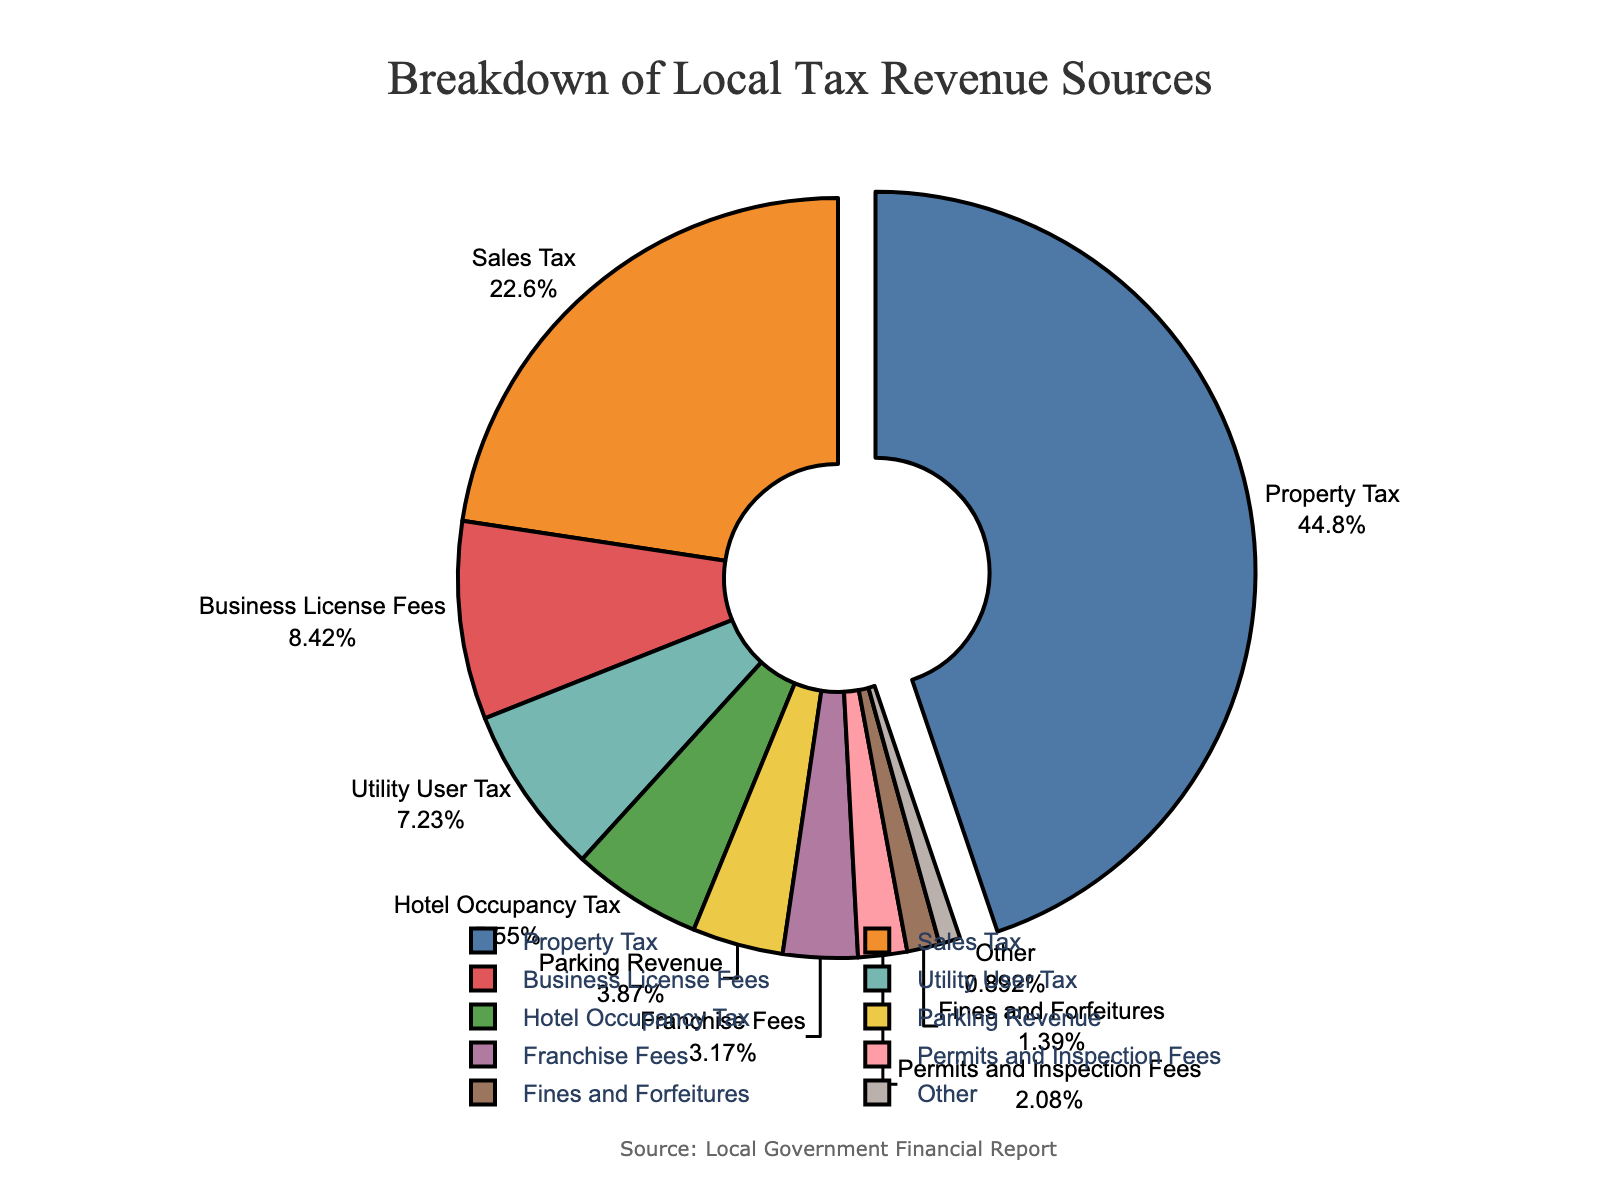Which tax revenue source contributes the most to the local tax revenue? The Property Tax segment on the pie chart shows the largest percentage, labeled as 45.2%.
Answer: Property Tax What is the combined percentage of Sales Tax and Business License Fees? Add the percentages of Sales Tax (22.8%) and Business License Fees (8.5%), which equals 22.8 + 8.5 = 31.3%.
Answer: 31.3% How does the percentage contribution of Utility User Tax compare to Parking Revenue? Utility User Tax contributes 7.3%, whereas Parking Revenue contributes 3.9%. Therefore, Utility User Tax is greater.
Answer: Utility User Tax is greater What is the difference in percentage contribution between Hotel Occupancy Tax and Fines and Forfeitures? Subtract the percentage of Fines and Forfeitures (1.4%) from Hotel Occupancy Tax (5.6%) which gives 5.6 - 1.4 = 4.2%.
Answer: 4.2% What are the tax revenue sources that contribute less than 5% each? The pie chart shows Fines and Forfeitures (1.4%), Permits and Inspection Fees (2.1%), Franchise Fees (3.2%), Parking Revenue (3.9%), and Other (0.9%) contribute less than 5%.
Answer: Fines and Forfeitures, Permits and Inspection Fees, Franchise Fees, Parking Revenue, Other What is the total percentage contribution of all tax revenue sources other than Property Tax? Subtract the percentage of Property Tax (45.2%) from 100% to get the total percentage of other sources, which is 100 - 45.2 = 54.8%.
Answer: 54.8% If Utility User Tax and Hotel Occupancy Tax were combined into a single category, what would be their total percentage? Add the percentages of Utility User Tax (7.3%) and Hotel Occupancy Tax (5.6%) which equals 7.3 + 5.6 = 12.9%.
Answer: 12.9% Which tax revenue sources are visually represented with the same color as the highest contributing tax revenue source? The highest contributing tax revenue source, Property Tax, is visually represented by the color (blue). This color is unique to Property Tax in the pie chart.
Answer: Only Property Tax Among the categories contributing less than 10%, which tax revenue source has the highest percentage? Business License Fees contribute 8.5%, which is the highest among categories with less than 10% contribution.
Answer: Business License Fees What is the average percentage contribution of the categories labeled as Hotel Occupancy Tax, Parking Revenue, and Franchise Fees? Add the percentages of Hotel Occupancy Tax (5.6%), Parking Revenue (3.9%), and Franchise Fees (3.2%), then divide by 3: (5.6 + 3.9 + 3.2) / 3 = 4.23%.
Answer: 4.23% 